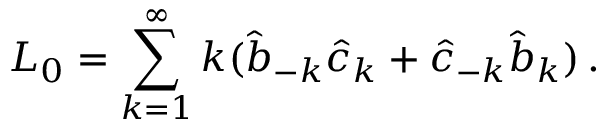Convert formula to latex. <formula><loc_0><loc_0><loc_500><loc_500>L _ { 0 } = \sum _ { k = 1 } ^ { \infty } k ( \hat { b } _ { - k } \hat { c } _ { k } + \hat { c } _ { - k } \hat { b } _ { k } ) \, .</formula> 